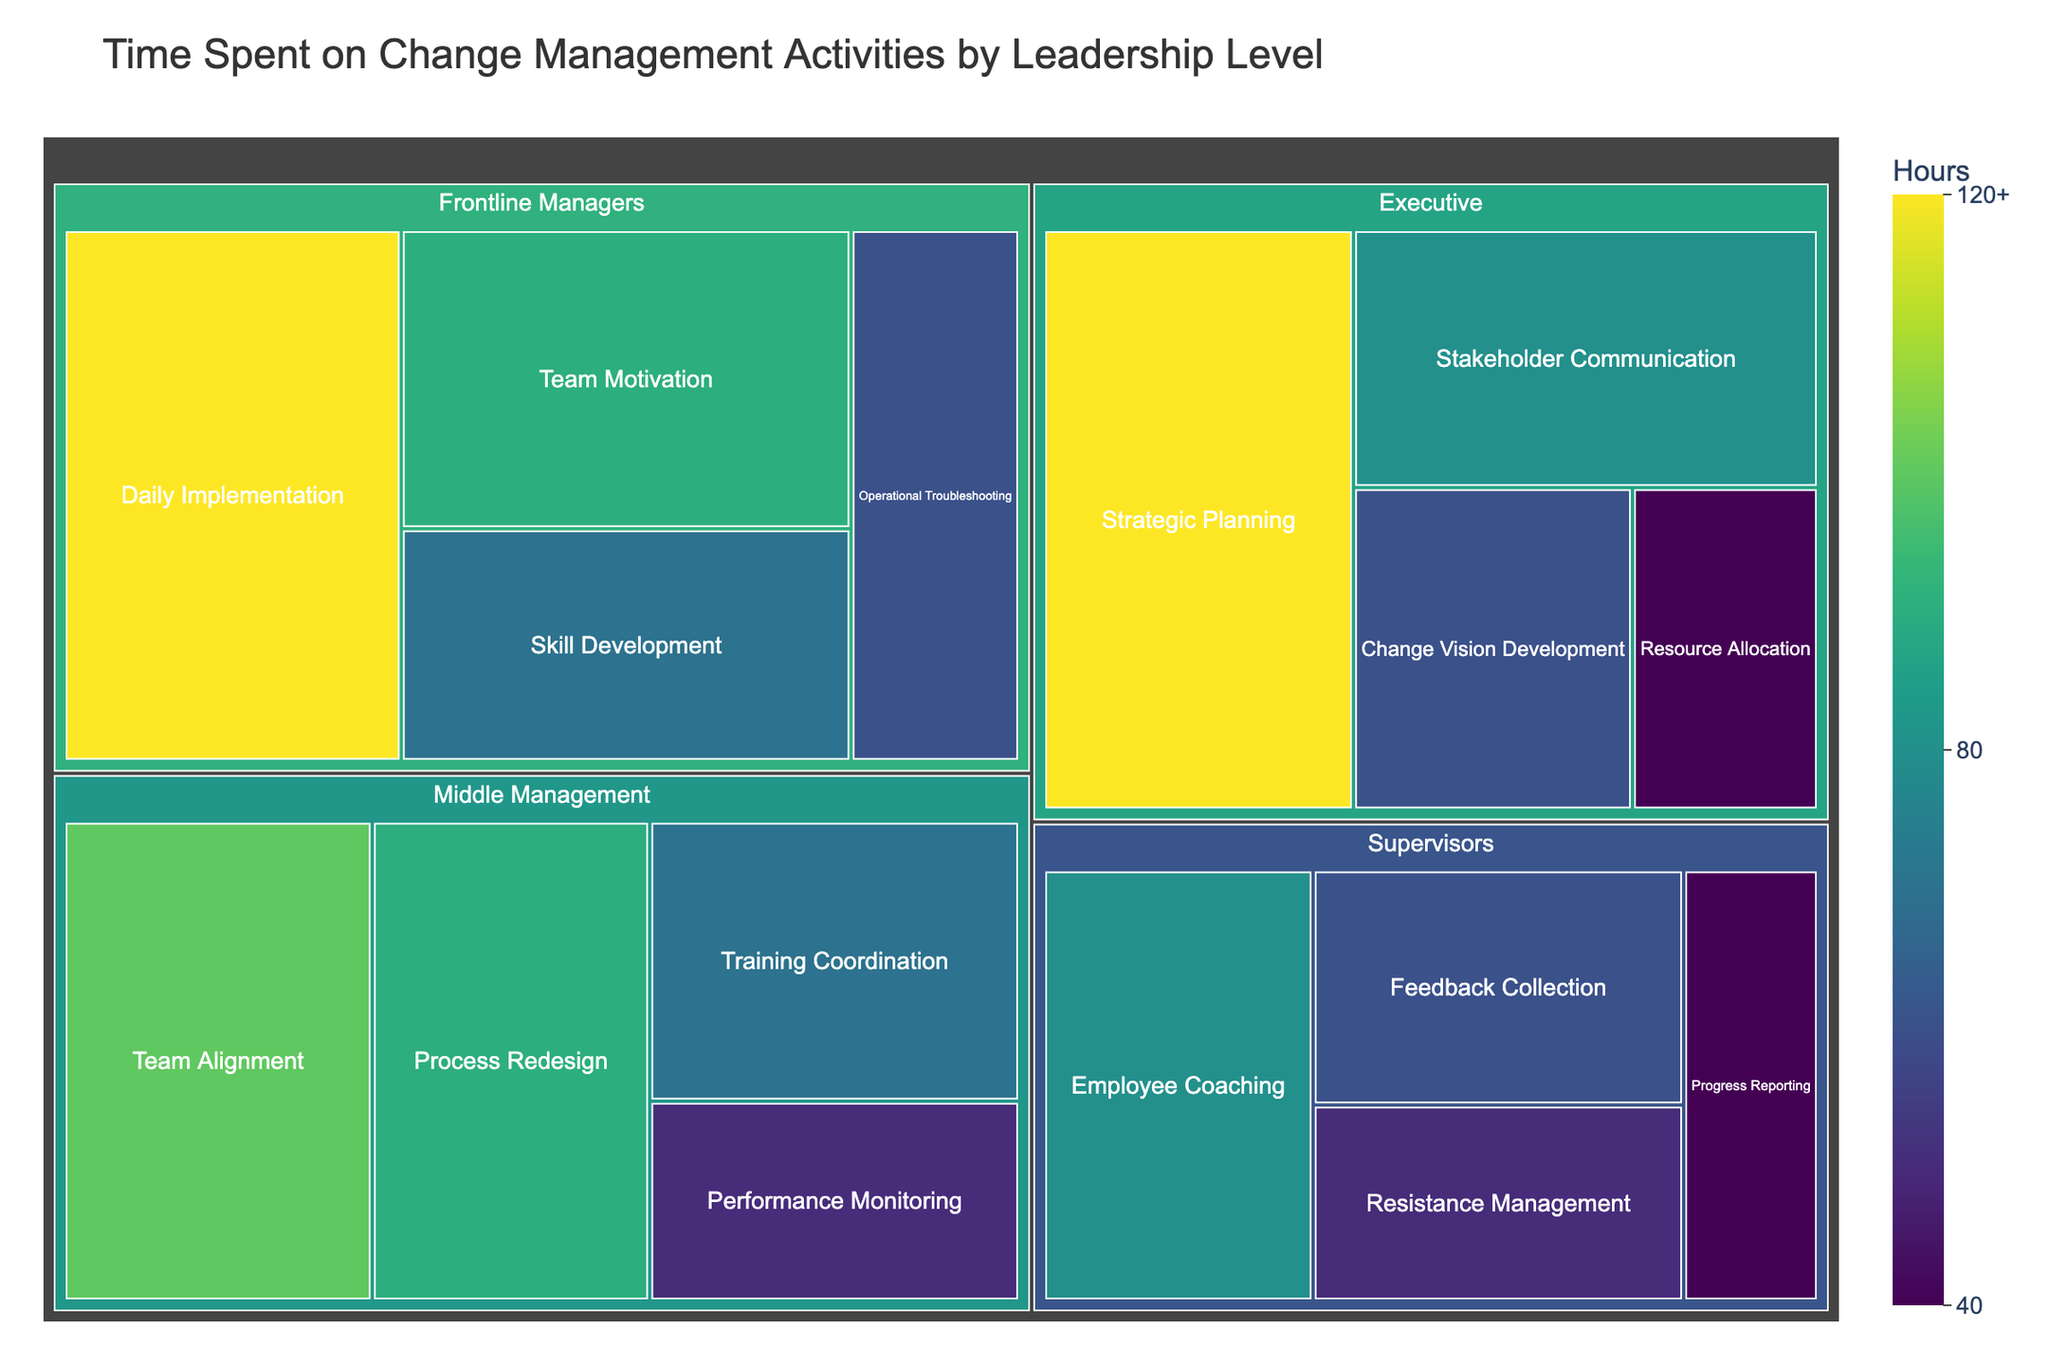what's the highest number of hours spent on a single activity? To find the highest number of hours, look for the activity with the largest area in the treemap and the darkest color shade. 'Strategic Planning' under 'Executive' has the largest area and dark color, signifying the highest number of hours.
Answer: 120 Which leadership level spends the most time on 'Training Coordination'? To answer, locate the leadership level associated with 'Training Coordination' and check the hours listed. 'Middle Management' is associated with 'Training Coordination' and spends 70 hours on it.
Answer: Middle Management What’s the total time spent by 'Executive' on all activities? To find this, sum the hours spent on each activity listed under 'Executive'. They are: 120 (Strategic Planning) + 80 (Stakeholder Communication) + 60 (Change Vision Development) + 40 (Resource Allocation) = 300.
Answer: 300 Which activity under 'Frontline Managers' takes the least time? Look at the activities under 'Frontline Managers' and identify the one with the smallest area and lightest color shade. 'Operational Troubleshooting' takes the least time at 60 hours.
Answer: Operational Troubleshooting Compare the total hours spent by 'Middle Management' and 'Supervisors'. Which group spends more time overall? Calculate the total hours for each group. Middle Management: 100 (Team Alignment) + 90 (Process Redesign) + 70 (Training Coordination) + 50 (Performance Monitoring) = 310. Supervisors: 80 (Employee Coaching) + 60 (Feedback Collection) + 50 (Resistance Management) + 40 (Progress Reporting) = 230. Middle Management spends more time.
Answer: Middle Management What is the average time spent by 'Supervisors' across all activities? Sum the hours spent on each activity under 'Supervisors' and divide by the number of activities. (80 + 60 + 50 + 40) / 4 = 57.5.
Answer: 57.5 Of all the activities, which one takes less than 50 hours? Look for activities with less than 50 hours in the treemap. Only 'Resource Allocation' under 'Executive' takes 40 hours, which is less than 50.
Answer: Resource Allocation Are there more activities categorized under 'Executive' or 'Frontline Managers'? Count the number of activities listed under both 'Executive' and 'Frontline Managers'. 'Executive' has 4 activities, while 'Frontline Managers' also has 4 activities.
Answer: Equal 